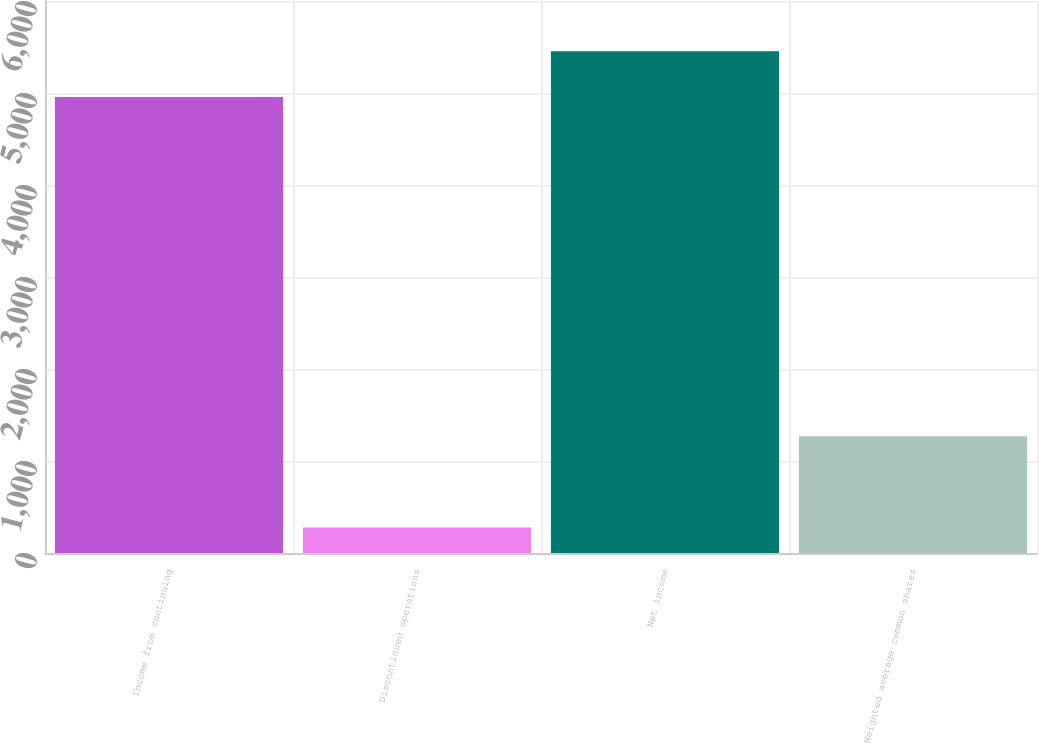Convert chart. <chart><loc_0><loc_0><loc_500><loc_500><bar_chart><fcel>Income from continuing<fcel>Discontinued operations<fcel>Net income<fcel>Weighted average common shares<nl><fcel>4957<fcel>277<fcel>5452.7<fcel>1268.4<nl></chart> 